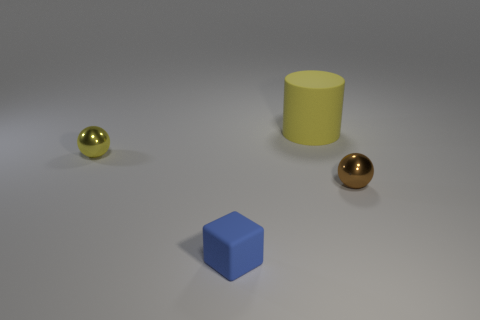Are there any other things that are the same size as the rubber cylinder?
Make the answer very short. No. There is a ball that is the same color as the big object; what material is it?
Make the answer very short. Metal. How many rubber objects are both behind the small blue block and in front of the large yellow cylinder?
Your response must be concise. 0. There is a ball on the left side of the shiny object on the right side of the large cylinder; what is it made of?
Provide a succinct answer. Metal. Are there any cubes made of the same material as the brown object?
Offer a terse response. No. There is a cube that is the same size as the yellow shiny sphere; what is its material?
Keep it short and to the point. Rubber. What size is the yellow thing that is in front of the yellow object behind the metal ball to the left of the brown metallic object?
Your answer should be compact. Small. Is there a yellow matte cylinder left of the tiny thing that is left of the small blue cube?
Ensure brevity in your answer.  No. There is a large yellow matte object; is its shape the same as the matte object in front of the yellow metallic thing?
Offer a terse response. No. There is a small shiny thing that is behind the tiny brown ball; what color is it?
Offer a very short reply. Yellow. 